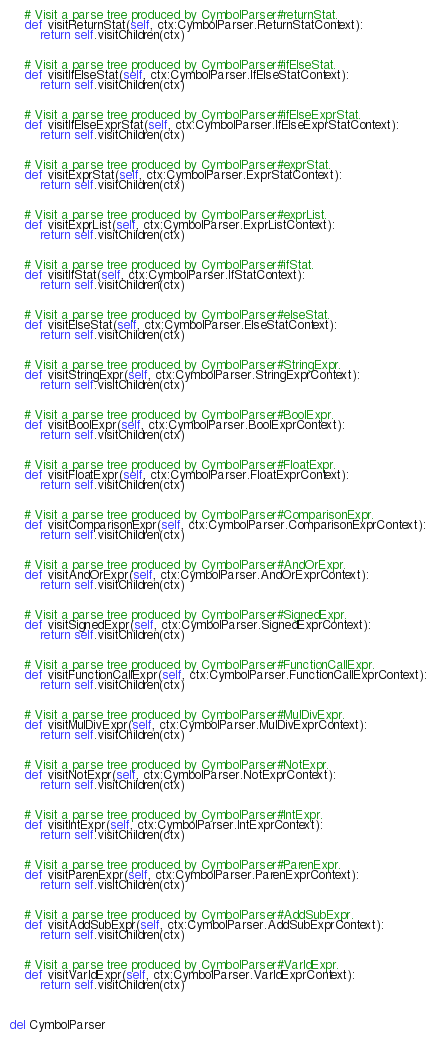<code> <loc_0><loc_0><loc_500><loc_500><_Python_>    # Visit a parse tree produced by CymbolParser#returnStat.
    def visitReturnStat(self, ctx:CymbolParser.ReturnStatContext):
        return self.visitChildren(ctx)


    # Visit a parse tree produced by CymbolParser#ifElseStat.
    def visitIfElseStat(self, ctx:CymbolParser.IfElseStatContext):
        return self.visitChildren(ctx)


    # Visit a parse tree produced by CymbolParser#ifElseExprStat.
    def visitIfElseExprStat(self, ctx:CymbolParser.IfElseExprStatContext):
        return self.visitChildren(ctx)


    # Visit a parse tree produced by CymbolParser#exprStat.
    def visitExprStat(self, ctx:CymbolParser.ExprStatContext):
        return self.visitChildren(ctx)


    # Visit a parse tree produced by CymbolParser#exprList.
    def visitExprList(self, ctx:CymbolParser.ExprListContext):
        return self.visitChildren(ctx)


    # Visit a parse tree produced by CymbolParser#ifStat.
    def visitIfStat(self, ctx:CymbolParser.IfStatContext):
        return self.visitChildren(ctx)


    # Visit a parse tree produced by CymbolParser#elseStat.
    def visitElseStat(self, ctx:CymbolParser.ElseStatContext):
        return self.visitChildren(ctx)


    # Visit a parse tree produced by CymbolParser#StringExpr.
    def visitStringExpr(self, ctx:CymbolParser.StringExprContext):
        return self.visitChildren(ctx)


    # Visit a parse tree produced by CymbolParser#BoolExpr.
    def visitBoolExpr(self, ctx:CymbolParser.BoolExprContext):
        return self.visitChildren(ctx)


    # Visit a parse tree produced by CymbolParser#FloatExpr.
    def visitFloatExpr(self, ctx:CymbolParser.FloatExprContext):
        return self.visitChildren(ctx)


    # Visit a parse tree produced by CymbolParser#ComparisonExpr.
    def visitComparisonExpr(self, ctx:CymbolParser.ComparisonExprContext):
        return self.visitChildren(ctx)


    # Visit a parse tree produced by CymbolParser#AndOrExpr.
    def visitAndOrExpr(self, ctx:CymbolParser.AndOrExprContext):
        return self.visitChildren(ctx)


    # Visit a parse tree produced by CymbolParser#SignedExpr.
    def visitSignedExpr(self, ctx:CymbolParser.SignedExprContext):
        return self.visitChildren(ctx)


    # Visit a parse tree produced by CymbolParser#FunctionCallExpr.
    def visitFunctionCallExpr(self, ctx:CymbolParser.FunctionCallExprContext):
        return self.visitChildren(ctx)


    # Visit a parse tree produced by CymbolParser#MulDivExpr.
    def visitMulDivExpr(self, ctx:CymbolParser.MulDivExprContext):
        return self.visitChildren(ctx)


    # Visit a parse tree produced by CymbolParser#NotExpr.
    def visitNotExpr(self, ctx:CymbolParser.NotExprContext):
        return self.visitChildren(ctx)


    # Visit a parse tree produced by CymbolParser#IntExpr.
    def visitIntExpr(self, ctx:CymbolParser.IntExprContext):
        return self.visitChildren(ctx)


    # Visit a parse tree produced by CymbolParser#ParenExpr.
    def visitParenExpr(self, ctx:CymbolParser.ParenExprContext):
        return self.visitChildren(ctx)


    # Visit a parse tree produced by CymbolParser#AddSubExpr.
    def visitAddSubExpr(self, ctx:CymbolParser.AddSubExprContext):
        return self.visitChildren(ctx)


    # Visit a parse tree produced by CymbolParser#VarIdExpr.
    def visitVarIdExpr(self, ctx:CymbolParser.VarIdExprContext):
        return self.visitChildren(ctx)



del CymbolParser</code> 